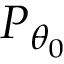Convert formula to latex. <formula><loc_0><loc_0><loc_500><loc_500>P _ { \theta _ { 0 } }</formula> 